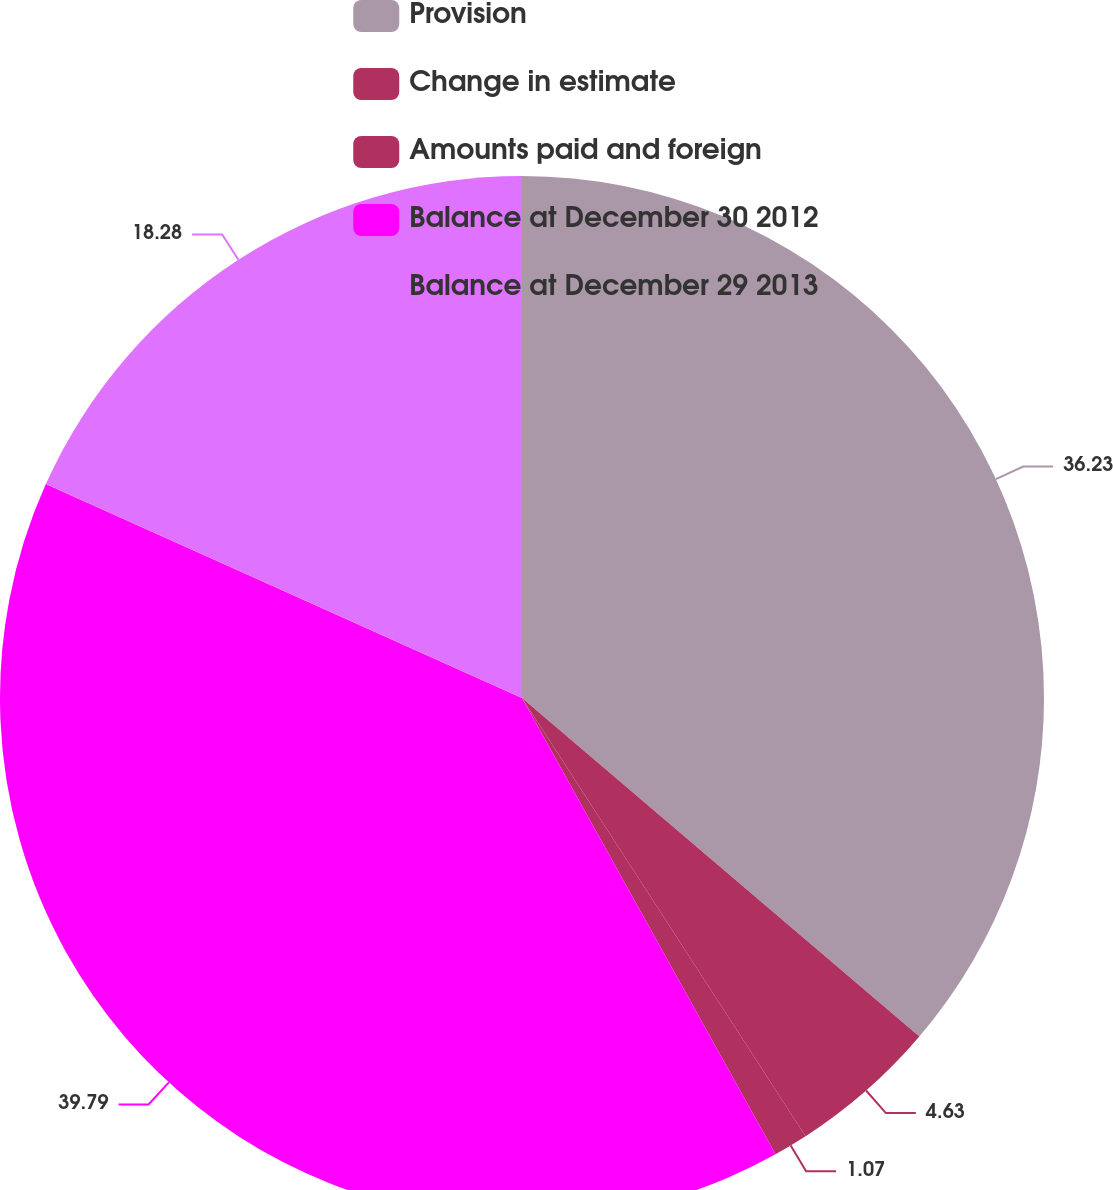<chart> <loc_0><loc_0><loc_500><loc_500><pie_chart><fcel>Provision<fcel>Change in estimate<fcel>Amounts paid and foreign<fcel>Balance at December 30 2012<fcel>Balance at December 29 2013<nl><fcel>36.23%<fcel>4.63%<fcel>1.07%<fcel>39.79%<fcel>18.28%<nl></chart> 